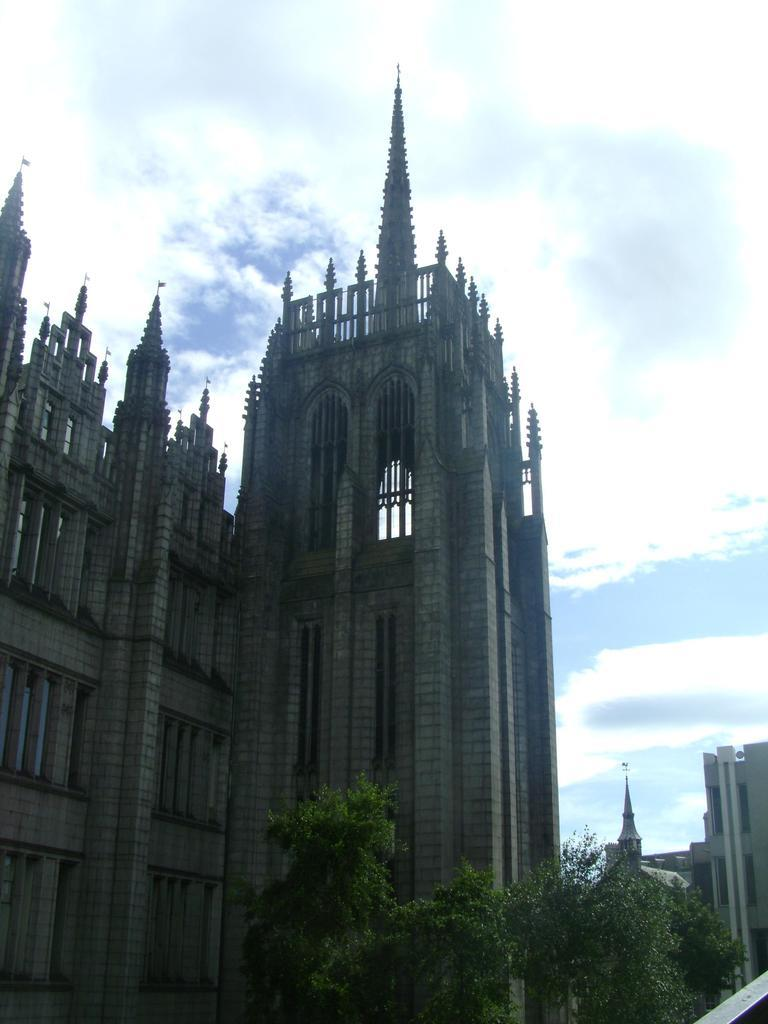What type of natural elements can be seen in the image? There are trees in the image. What type of man-made structures are visible in the background? There are buildings in the background of the image. What can be seen in the sky in the background of the image? There are clouds in the sky in the background of the image. What type of silk fabric is draped over the trees in the image? There is no silk fabric present in the image; the trees are not covered by any fabric. What type of marble material is used to construct the buildings in the image? The provided facts do not mention the materials used to construct the buildings, so we cannot determine if marble is used. 